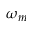Convert formula to latex. <formula><loc_0><loc_0><loc_500><loc_500>\omega _ { m }</formula> 